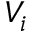<formula> <loc_0><loc_0><loc_500><loc_500>V _ { i }</formula> 